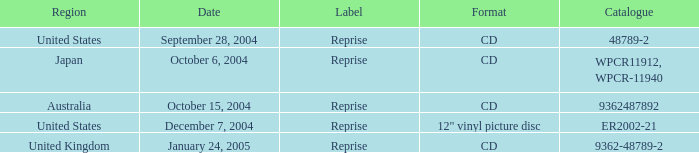Name the october 15, 2004 catalogue 9362487892.0. 